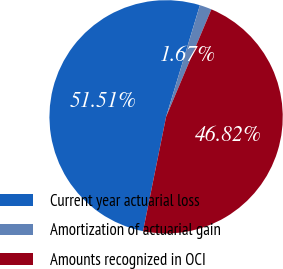Convert chart to OTSL. <chart><loc_0><loc_0><loc_500><loc_500><pie_chart><fcel>Current year actuarial loss<fcel>Amortization of actuarial gain<fcel>Amounts recognized in OCI<nl><fcel>51.51%<fcel>1.67%<fcel>46.82%<nl></chart> 